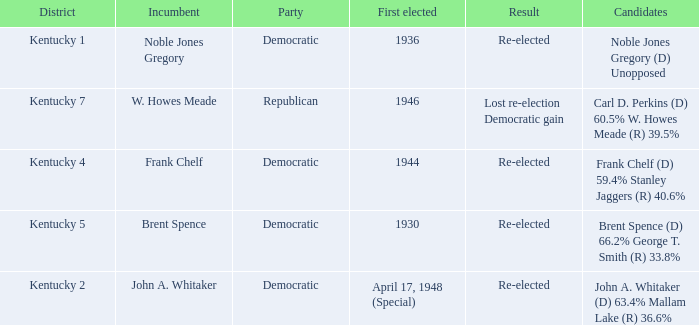What was the result of the election incumbent Brent Spence took place in? Re-elected. 